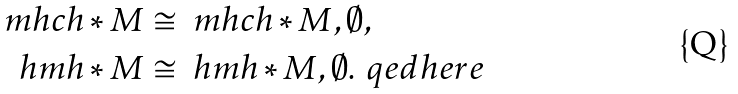<formula> <loc_0><loc_0><loc_500><loc_500>\ m h c h * M & \cong \ m h c h * { M , \emptyset } , \\ \ h m h * M & \cong \ h m h * { M , \emptyset } . \ q e d h e r e</formula> 